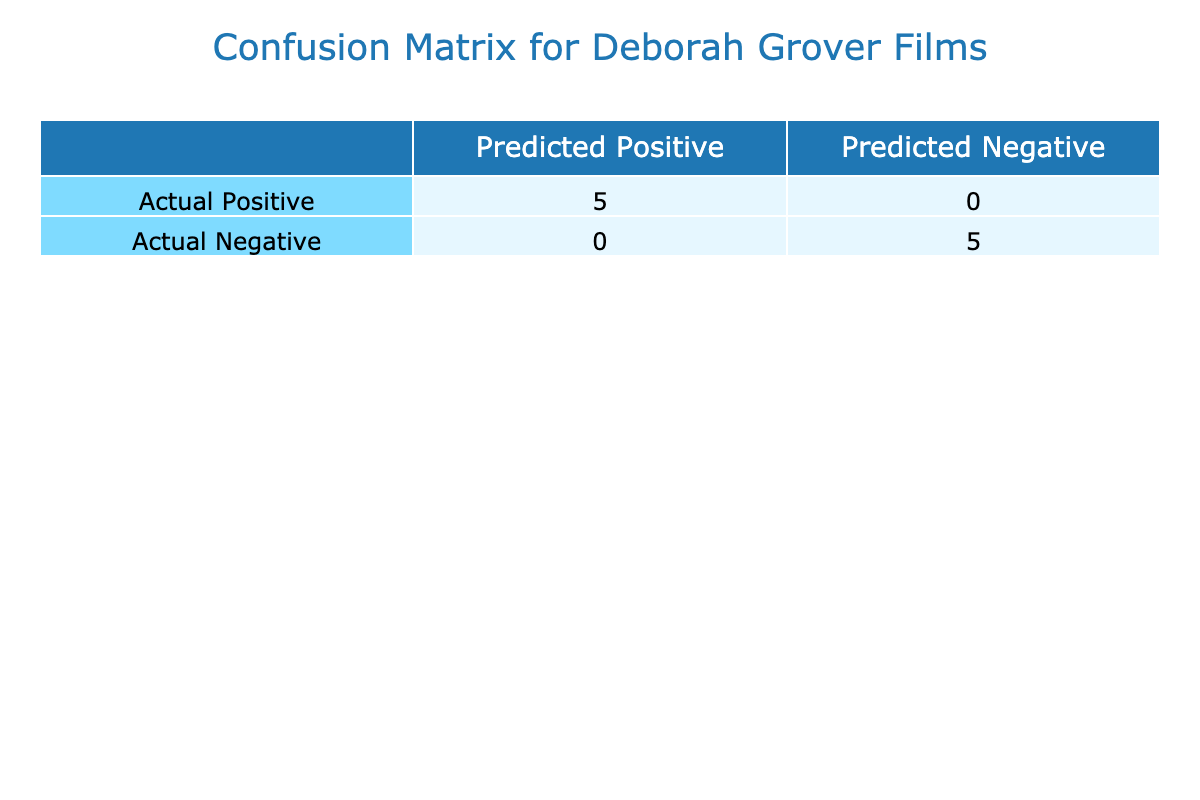What is the total number of true positives in Deborah Grover's films? The true positives represent films where awards were won and the predicted outcome was positive (Award Status is TRUE). Counting the films that fulfill this condition from the table, we find three films: "Where the Truth Lies," "Shattered City: The Halifax Explosion," and "The Good Times Are Killing Me." This gives us a total of 3 true positives.
Answer: 3 How many films did not win awards but were predicted to have won? The false positives reflect films that did not win an award but were incorrectly predicted to have done so (Award Status is TRUE). Scanning through the table, we have no films that fit this criteria since awarded films match their Award Status. Therefore, there is 0 false positives.
Answer: 0 What percentage of the films that won an award actually had a positive prediction? To calculate this percentage, we need to find the number of true positives and the total number of films that won awards. The total number of films won awards is 5 (Where the Truth Lies, Shattered City: The Halifax Explosion, The Good Times Are Killing Me, The Unseen, The Last Argument). The total true positives is 3. Thus, the percentage is (3/5) * 100 = 60%.
Answer: 60% Are there any films with an audience rating above 7.5 that did not win awards? Looking at the films with an audience rating above 7.5, we have "Shattered City: The Halifax Explosion" (8.0), "The Unseen" (7.8), and "The Last Argument" (8.2). However, both "The Good Times Are Killing Me" and these films won an award, indicating there are no films meeting the criteria of a rating above 7.5 without winning an award.
Answer: No What is the difference between true negatives and false negatives? True negatives represent films that did not win awards and were correctly predicted to not have won (Award Status is FALSE). The films fitting this category are "Evening," "Random Harvest," "Beastly," "Starlit Adventures," and "More Than Meets the Eye," totaling 5. False negatives are films that did win awards but were incorrectly predicted not to have won; the table shows there are 0 such films. Therefore, the difference is 5 true negatives - 0 false negatives = 5.
Answer: 5 